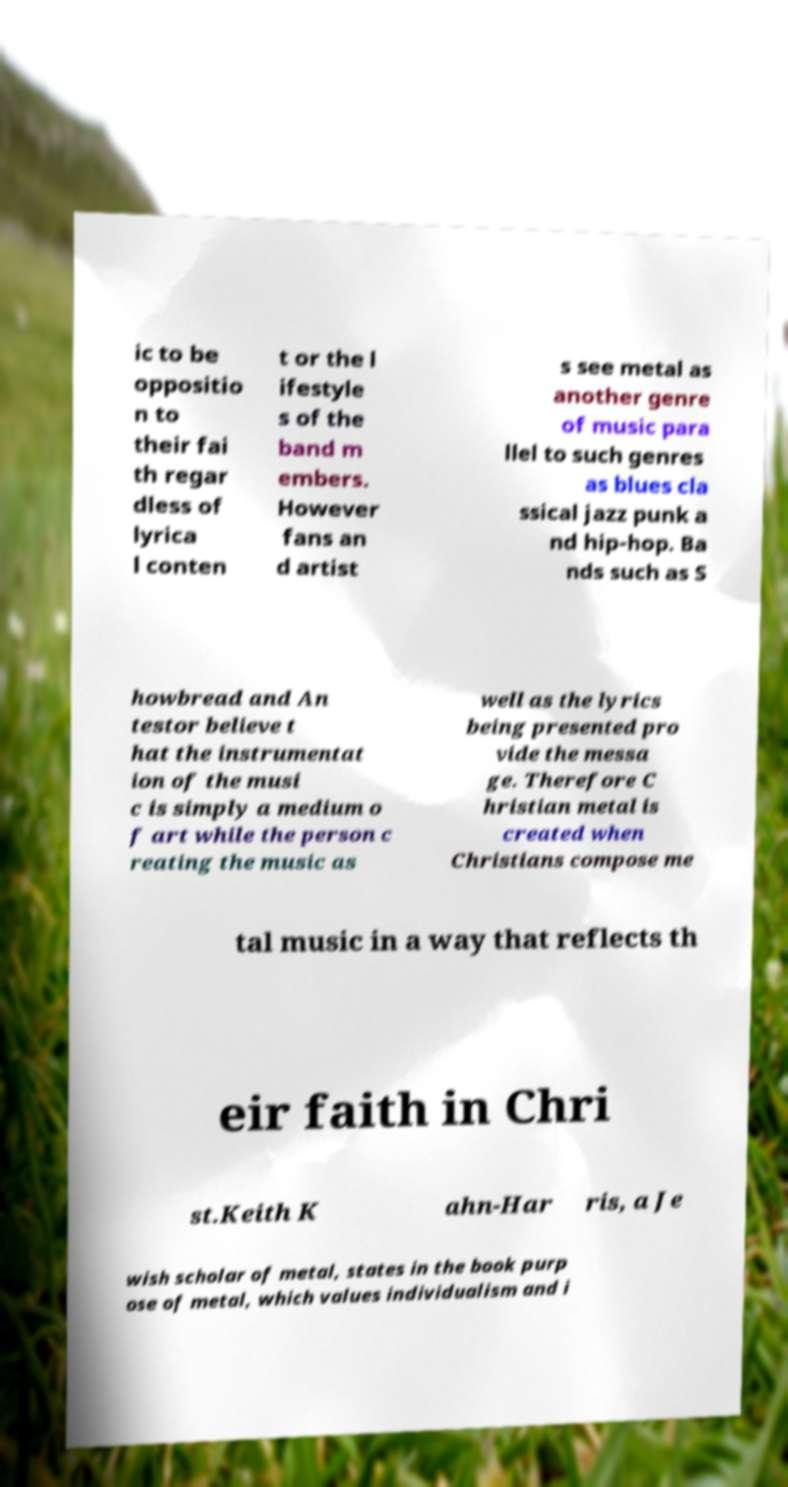Please read and relay the text visible in this image. What does it say? ic to be oppositio n to their fai th regar dless of lyrica l conten t or the l ifestyle s of the band m embers. However fans an d artist s see metal as another genre of music para llel to such genres as blues cla ssical jazz punk a nd hip-hop. Ba nds such as S howbread and An testor believe t hat the instrumentat ion of the musi c is simply a medium o f art while the person c reating the music as well as the lyrics being presented pro vide the messa ge. Therefore C hristian metal is created when Christians compose me tal music in a way that reflects th eir faith in Chri st.Keith K ahn-Har ris, a Je wish scholar of metal, states in the book purp ose of metal, which values individualism and i 